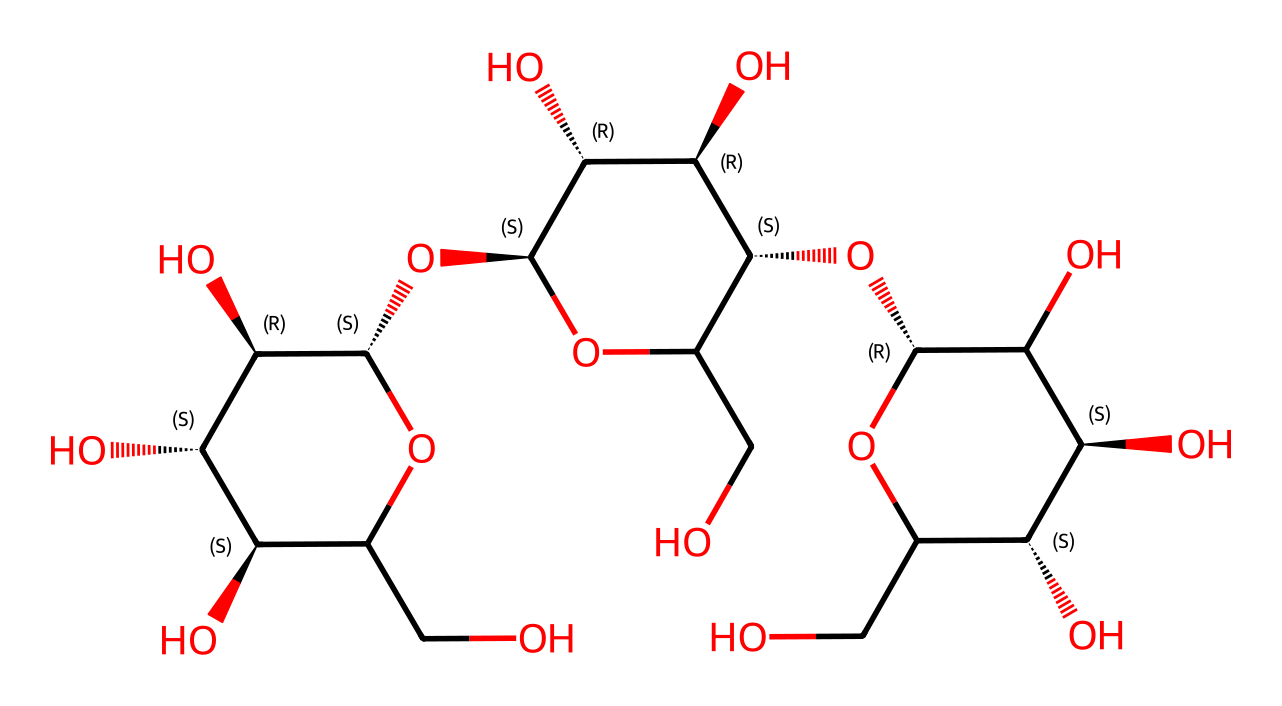What is the primary function of cellulose in plants? Cellulose primarily provides structural support in plant cell walls. Its rigid structure helps maintain cell shape and enables the plant to withstand various stresses.
Answer: structural support How many carbon atoms are present in this cellulose structure? By counting the carbon atoms in the SMILES representation, we see there are 6.
Answer: 6 Which functional group is prominently featured in cellulose? The hydroxyl (OH) groups are prominent in cellulose, which contribute to its hydrophilicity and ability to form hydrogen bonds.
Answer: hydroxyl What type of carbohydrate is cellulose classified as? Cellulose is classified as a polysaccharide because it consists of long chains of monosaccharides (glucose units) linked together.
Answer: polysaccharide How does the configuration of glucose units influence cellulose's properties? The specific configuration (beta-D-glucose) of the glucose units results in a straight chain, which enhances hydrogen bonding between adjacent chains, contributing to its strength and rigidity.
Answer: beta-D-glucose What is notable about the bonding in cellulose compared to starch? In cellulose, beta-glycosidic bonds link the glucose units, whereas in starch, the bonds are typically alpha-glycosidic, leading to a difference in structure and energy storage capability.
Answer: beta-glycosidic What is the solubility of cellulose in water? Cellulose is insoluble in water due to its extensive hydrogen bonding that stabilizes its structure and prevents interactions with water molecules.
Answer: insoluble 